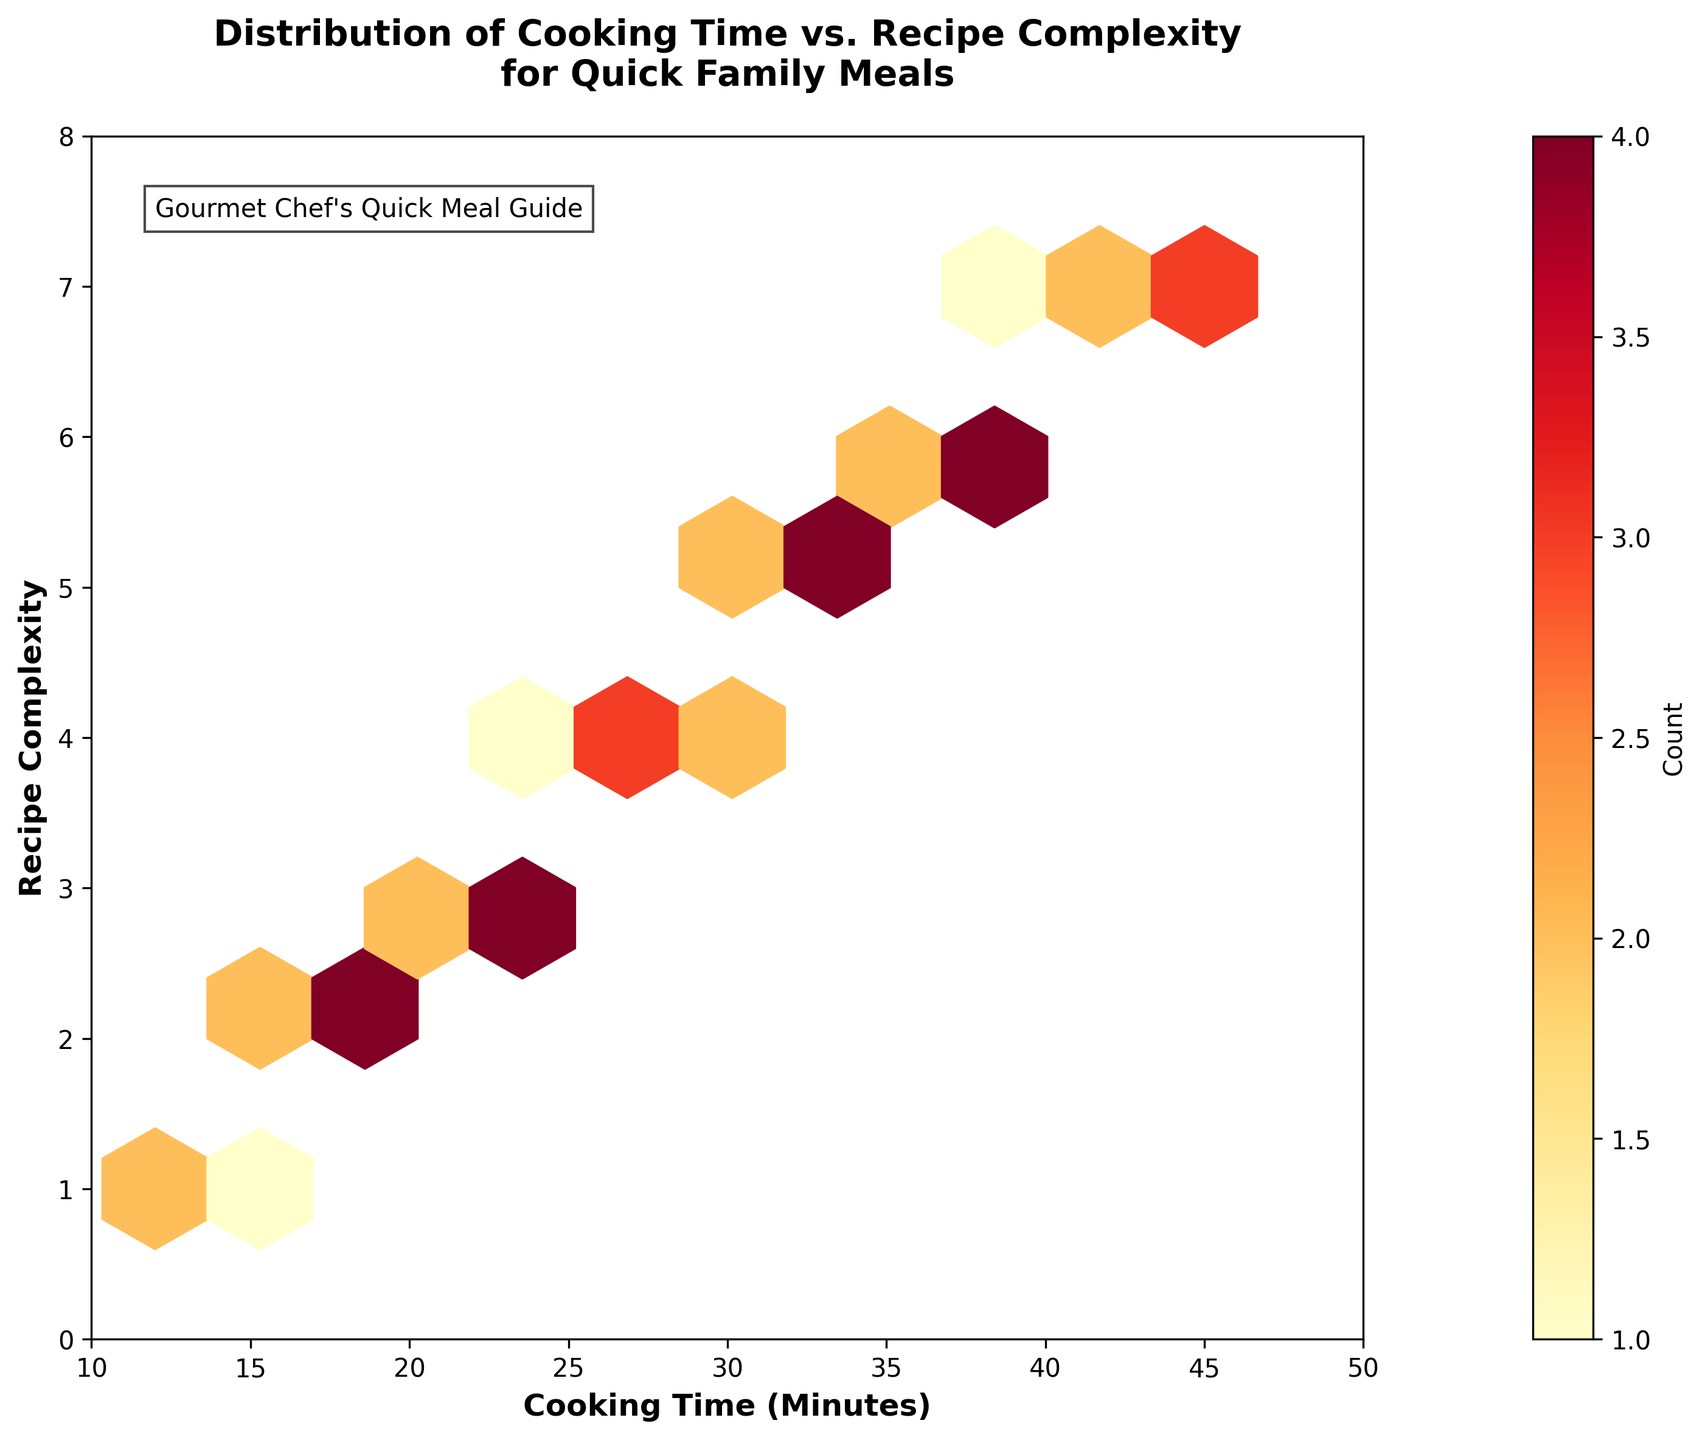What's the title of the plot? The title of the plot is written at the top and reads "Distribution of Cooking Time vs. Recipe Complexity for Quick Family Meals," indicating the key insight the plot aims to convey.
Answer: Distribution of Cooking Time vs. Recipe Complexity for Quick Family Meals What does the color intensity indicate in this plot? The color intensity in the hexbin plot indicates the count of data points within each hexagonal bin. The colorbar on the right helps interpret this, where darker shades represent higher counts.
Answer: Count of data points What's the range of Cooking Time displayed on the x-axis? The x-axis is labeled "Cooking Time (Minutes)," and it ranges from 10 to 50 minutes, as shown by the axis ticks and further confirmed by the boundaries of the plot.
Answer: 10 to 50 minutes How many axis labels are there on the y-axis, and what are these labels? The y-axis is labeled "Recipe Complexity," and the axis includes the labels 0 through 8 to cover the range of complexity levels for the recipes.
Answer: Nine labels (0 to 8) What is the most frequent combination of cooking time and recipe complexity? To find the most frequent combination, look for the darkest hexagon, which indicates the highest count. In this plot, the darkest hexagon is around a cooking time of 25 minutes and a recipe complexity of 4.
Answer: Cooking time of 25 minutes and recipe complexity of 4 Which area of the plot has the least data density? The least data density is shown by the lightest shades or by hexagons that are harder to see, indicating low data counts. This is found at the lower extremes of both cooking time and recipe complexity, around 10-15 minutes and 1-2 complexity.
Answer: 10-15 minutes and 1-2 complexity What cooking time and complexity fall into the highest data density area? The highest data density area is where the hexagons are darkest, roughly around the range of 25-30 minutes for cooking time and 3-4 for complexity, indicating these values are common.
Answer: 25-30 minutes and 3-4 complexity Is there any cooking time that has a recipe complexity of 1? Yes, there are hexagons corresponding to a recipe complexity of 1 at cooking times of approximately 12, 14, and 13 minutes. These lighter hexagons indicate a lower frequency.
Answer: Yes Do longer cooking times correlate with higher recipe complexity? Yes, there is a general linear trend in the plot indicating that as cooking time increases, recipe complexity also tends to increase. The hexbin distribution from lower-left to upper-right confirms this observation.
Answer: Yes 